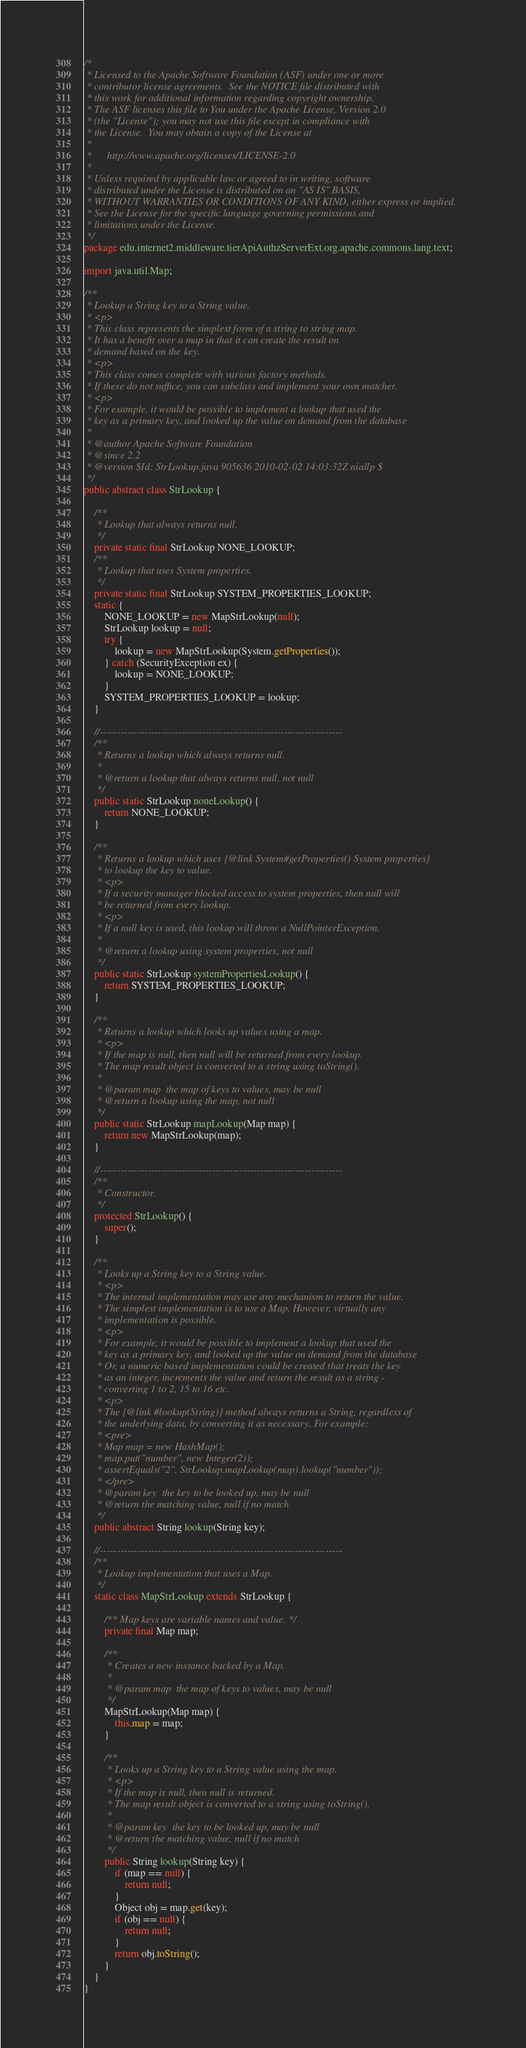Convert code to text. <code><loc_0><loc_0><loc_500><loc_500><_Java_>/*
 * Licensed to the Apache Software Foundation (ASF) under one or more
 * contributor license agreements.  See the NOTICE file distributed with
 * this work for additional information regarding copyright ownership.
 * The ASF licenses this file to You under the Apache License, Version 2.0
 * (the "License"); you may not use this file except in compliance with
 * the License.  You may obtain a copy of the License at
 * 
 *      http://www.apache.org/licenses/LICENSE-2.0
 * 
 * Unless required by applicable law or agreed to in writing, software
 * distributed under the License is distributed on an "AS IS" BASIS,
 * WITHOUT WARRANTIES OR CONDITIONS OF ANY KIND, either express or implied.
 * See the License for the specific language governing permissions and
 * limitations under the License.
 */
package edu.internet2.middleware.tierApiAuthzServerExt.org.apache.commons.lang.text;

import java.util.Map;

/**
 * Lookup a String key to a String value.
 * <p>
 * This class represents the simplest form of a string to string map.
 * It has a benefit over a map in that it can create the result on
 * demand based on the key.
 * <p>
 * This class comes complete with various factory methods.
 * If these do not suffice, you can subclass and implement your own matcher.
 * <p>
 * For example, it would be possible to implement a lookup that used the
 * key as a primary key, and looked up the value on demand from the database
 *
 * @author Apache Software Foundation
 * @since 2.2
 * @version $Id: StrLookup.java 905636 2010-02-02 14:03:32Z niallp $
 */
public abstract class StrLookup {

    /**
     * Lookup that always returns null.
     */
    private static final StrLookup NONE_LOOKUP;
    /**
     * Lookup that uses System properties.
     */
    private static final StrLookup SYSTEM_PROPERTIES_LOOKUP;
    static {
        NONE_LOOKUP = new MapStrLookup(null);
        StrLookup lookup = null;
        try {
            lookup = new MapStrLookup(System.getProperties());
        } catch (SecurityException ex) {
            lookup = NONE_LOOKUP;
        }
        SYSTEM_PROPERTIES_LOOKUP = lookup;
    }

    //-----------------------------------------------------------------------
    /**
     * Returns a lookup which always returns null.
     *
     * @return a lookup that always returns null, not null
     */
    public static StrLookup noneLookup() {
        return NONE_LOOKUP;
    }

    /**
     * Returns a lookup which uses {@link System#getProperties() System properties}
     * to lookup the key to value.
     * <p>
     * If a security manager blocked access to system properties, then null will
     * be returned from every lookup.
     * <p>
     * If a null key is used, this lookup will throw a NullPointerException.
     *
     * @return a lookup using system properties, not null
     */
    public static StrLookup systemPropertiesLookup() {
        return SYSTEM_PROPERTIES_LOOKUP;
    }

    /**
     * Returns a lookup which looks up values using a map.
     * <p>
     * If the map is null, then null will be returned from every lookup.
     * The map result object is converted to a string using toString().
     *
     * @param map  the map of keys to values, may be null
     * @return a lookup using the map, not null
     */
    public static StrLookup mapLookup(Map map) {
        return new MapStrLookup(map);
    }

    //-----------------------------------------------------------------------
    /**
     * Constructor.
     */
    protected StrLookup() {
        super();
    }

    /**
     * Looks up a String key to a String value.
     * <p>
     * The internal implementation may use any mechanism to return the value.
     * The simplest implementation is to use a Map. However, virtually any
     * implementation is possible.
     * <p>
     * For example, it would be possible to implement a lookup that used the
     * key as a primary key, and looked up the value on demand from the database
     * Or, a numeric based implementation could be created that treats the key
     * as an integer, increments the value and return the result as a string -
     * converting 1 to 2, 15 to 16 etc.
     * <p>
     * The {@link #lookup(String)} method always returns a String, regardless of
     * the underlying data, by converting it as necessary. For example:
     * <pre>
     * Map map = new HashMap();
     * map.put("number", new Integer(2));
     * assertEquals("2", StrLookup.mapLookup(map).lookup("number"));
     * </pre>
     * @param key  the key to be looked up, may be null
     * @return the matching value, null if no match
     */
    public abstract String lookup(String key);

    //-----------------------------------------------------------------------
    /**
     * Lookup implementation that uses a Map.
     */
    static class MapStrLookup extends StrLookup {

        /** Map keys are variable names and value. */
        private final Map map;

        /**
         * Creates a new instance backed by a Map.
         *
         * @param map  the map of keys to values, may be null
         */
        MapStrLookup(Map map) {
            this.map = map;
        }

        /**
         * Looks up a String key to a String value using the map.
         * <p>
         * If the map is null, then null is returned.
         * The map result object is converted to a string using toString().
         *
         * @param key  the key to be looked up, may be null
         * @return the matching value, null if no match
         */
        public String lookup(String key) {
            if (map == null) {
                return null;
            }
            Object obj = map.get(key);
            if (obj == null) {
                return null;
            }
            return obj.toString();
        }
    }
}
</code> 